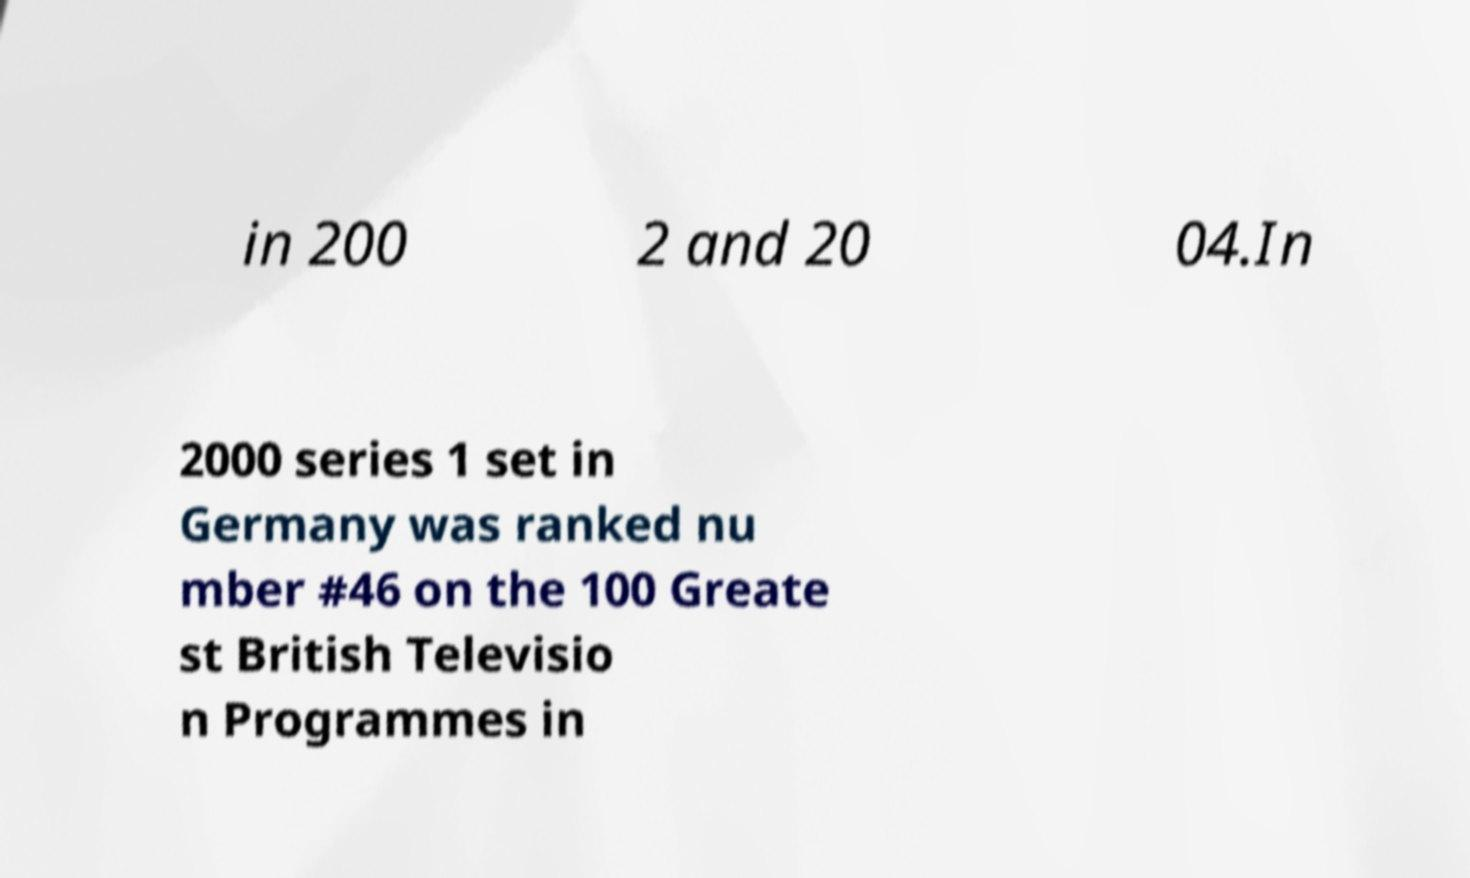Could you assist in decoding the text presented in this image and type it out clearly? in 200 2 and 20 04.In 2000 series 1 set in Germany was ranked nu mber #46 on the 100 Greate st British Televisio n Programmes in 